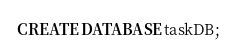Convert code to text. <code><loc_0><loc_0><loc_500><loc_500><_SQL_>CREATE DATABASE taskDB;</code> 